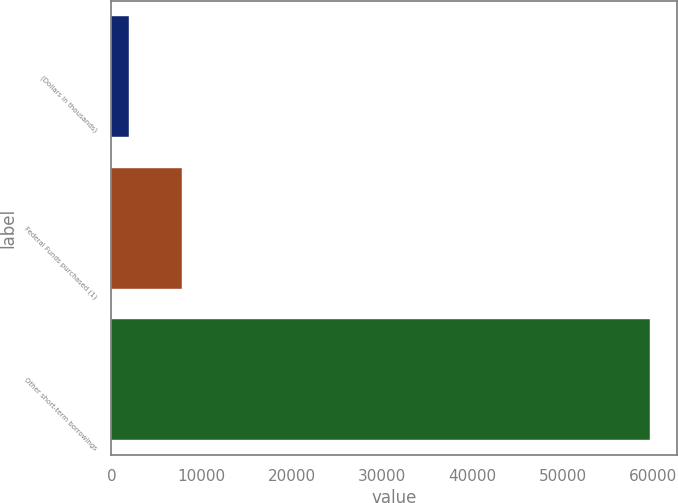<chart> <loc_0><loc_0><loc_500><loc_500><bar_chart><fcel>(Dollars in thousands)<fcel>Federal Funds purchased (1)<fcel>Other short-term borrowings<nl><fcel>2010<fcel>7782.5<fcel>59735<nl></chart> 